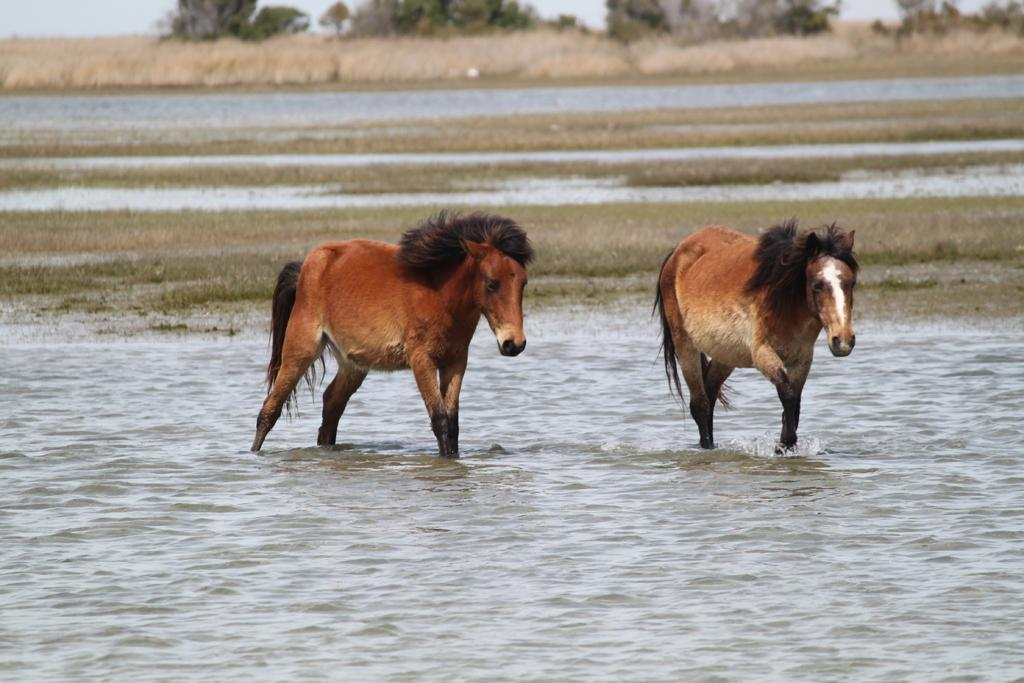How many animals are in the image? There are two animals in the image. What colors are the animals in the image? The animals are in black, brown, and white colors. Where are the animals located in the image? The animals are in the water. What can be seen in the background of the image? There is grass, many trees, and the sky visible in the background of the image. What is the opinion of the dime about the winter season in the image? There is no dime present in the image, and therefore no opinion can be attributed to it. 